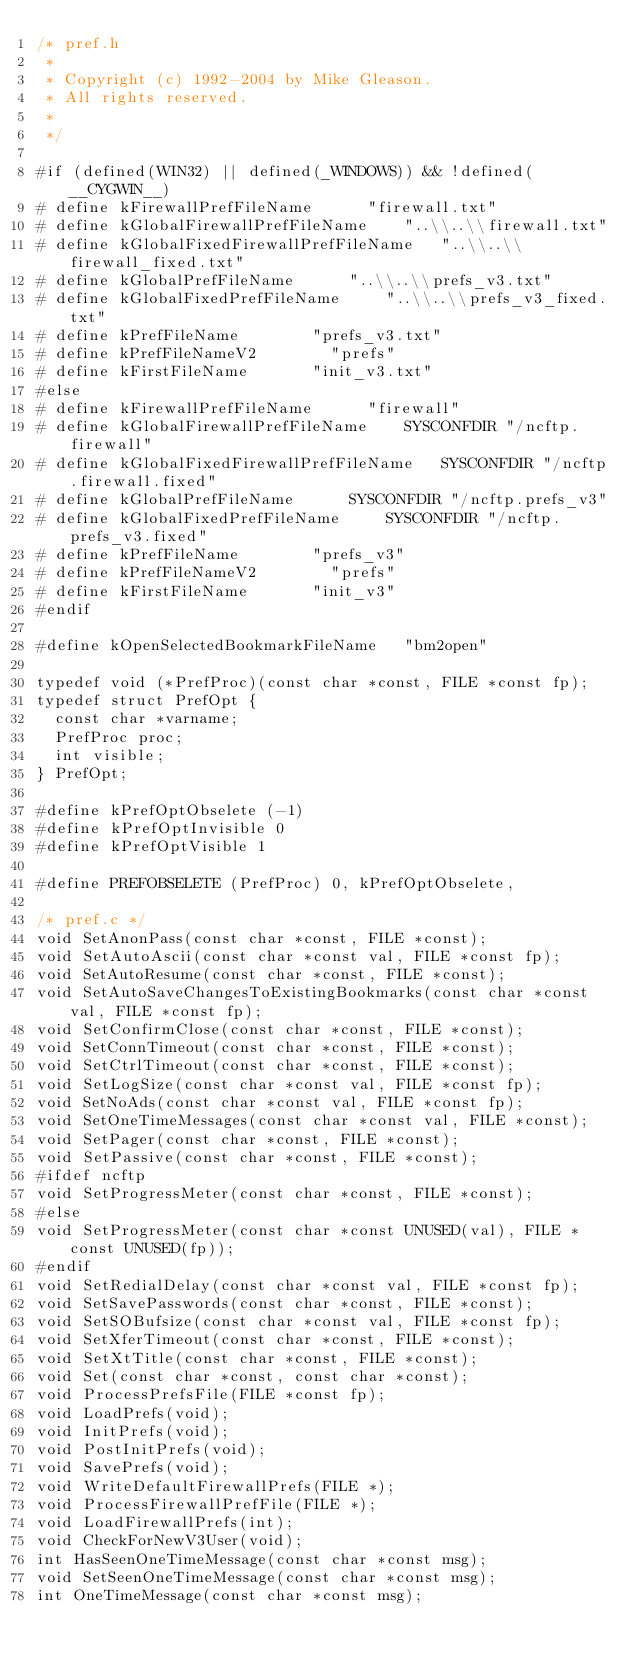Convert code to text. <code><loc_0><loc_0><loc_500><loc_500><_C_>/* pref.h
 *
 * Copyright (c) 1992-2004 by Mike Gleason.
 * All rights reserved.
 * 
 */

#if (defined(WIN32) || defined(_WINDOWS)) && !defined(__CYGWIN__)
#	define kFirewallPrefFileName			"firewall.txt"
#	define kGlobalFirewallPrefFileName		"..\\..\\firewall.txt"
#	define kGlobalFixedFirewallPrefFileName		"..\\..\\firewall_fixed.txt"
#	define kGlobalPrefFileName			"..\\..\\prefs_v3.txt"
#	define kGlobalFixedPrefFileName			"..\\..\\prefs_v3_fixed.txt"
#	define kPrefFileName				"prefs_v3.txt"
#	define kPrefFileNameV2				"prefs"
#	define kFirstFileName				"init_v3.txt"
#else
#	define kFirewallPrefFileName			"firewall"
#	define kGlobalFirewallPrefFileName		SYSCONFDIR "/ncftp.firewall"
#	define kGlobalFixedFirewallPrefFileName		SYSCONFDIR "/ncftp.firewall.fixed"
#	define kGlobalPrefFileName			SYSCONFDIR "/ncftp.prefs_v3"
#	define kGlobalFixedPrefFileName			SYSCONFDIR "/ncftp.prefs_v3.fixed"
#	define kPrefFileName				"prefs_v3"
#	define kPrefFileNameV2				"prefs"
#	define kFirstFileName				"init_v3"
#endif

#define kOpenSelectedBookmarkFileName		"bm2open"

typedef void (*PrefProc)(const char *const, FILE *const fp);
typedef struct PrefOpt {
	const char *varname;
	PrefProc proc;
	int visible;
} PrefOpt;

#define kPrefOptObselete (-1)
#define kPrefOptInvisible 0
#define kPrefOptVisible 1

#define PREFOBSELETE (PrefProc) 0, kPrefOptObselete,

/* pref.c */
void SetAnonPass(const char *const, FILE *const);
void SetAutoAscii(const char *const val, FILE *const fp);
void SetAutoResume(const char *const, FILE *const);
void SetAutoSaveChangesToExistingBookmarks(const char *const val, FILE *const fp);
void SetConfirmClose(const char *const, FILE *const);
void SetConnTimeout(const char *const, FILE *const);
void SetCtrlTimeout(const char *const, FILE *const);
void SetLogSize(const char *const val, FILE *const fp);
void SetNoAds(const char *const val, FILE *const fp);
void SetOneTimeMessages(const char *const val, FILE *const);
void SetPager(const char *const, FILE *const);
void SetPassive(const char *const, FILE *const);
#ifdef ncftp
void SetProgressMeter(const char *const, FILE *const);
#else
void SetProgressMeter(const char *const UNUSED(val), FILE *const UNUSED(fp));
#endif
void SetRedialDelay(const char *const val, FILE *const fp);
void SetSavePasswords(const char *const, FILE *const);
void SetSOBufsize(const char *const val, FILE *const fp);
void SetXferTimeout(const char *const, FILE *const);
void SetXtTitle(const char *const, FILE *const);
void Set(const char *const, const char *const);
void ProcessPrefsFile(FILE *const fp);
void LoadPrefs(void);
void InitPrefs(void);
void PostInitPrefs(void);
void SavePrefs(void);
void WriteDefaultFirewallPrefs(FILE *);
void ProcessFirewallPrefFile(FILE *);
void LoadFirewallPrefs(int);
void CheckForNewV3User(void);
int HasSeenOneTimeMessage(const char *const msg);
void SetSeenOneTimeMessage(const char *const msg);
int OneTimeMessage(const char *const msg);
</code> 